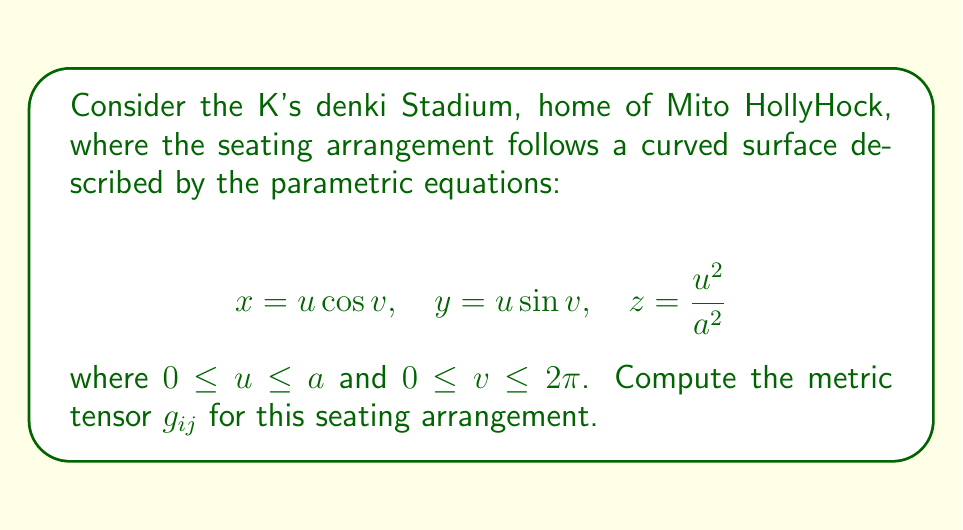Could you help me with this problem? Let's approach this step-by-step:

1) The metric tensor $g_{ij}$ is given by the dot product of the partial derivatives of the position vector with respect to the parameters:

   $$g_{ij} = \frac{\partial \mathbf{r}}{\partial x^i} \cdot \frac{\partial \mathbf{r}}{\partial x^j}$$

   where $\mathbf{r} = (x, y, z)$ and $(x^1, x^2) = (u, v)$.

2) Let's calculate the partial derivatives:

   $$\frac{\partial \mathbf{r}}{\partial u} = (\cos v, \sin v, \frac{2u}{a^2})$$
   $$\frac{\partial \mathbf{r}}{\partial v} = (-u\sin v, u\cos v, 0)$$

3) Now, let's compute each component of the metric tensor:

   $$g_{11} = \frac{\partial \mathbf{r}}{\partial u} \cdot \frac{\partial \mathbf{r}}{\partial u} = \cos^2 v + \sin^2 v + \frac{4u^2}{a^4} = 1 + \frac{4u^2}{a^4}$$

   $$g_{12} = g_{21} = \frac{\partial \mathbf{r}}{\partial u} \cdot \frac{\partial \mathbf{r}}{\partial v} = -u\sin v \cos v + u\sin v \cos v = 0$$

   $$g_{22} = \frac{\partial \mathbf{r}}{\partial v} \cdot \frac{\partial \mathbf{r}}{\partial v} = u^2\sin^2 v + u^2\cos^2 v = u^2$$

4) Therefore, the metric tensor is:

   $$g_{ij} = \begin{pmatrix} 
   1 + \frac{4u^2}{a^4} & 0 \\
   0 & u^2
   \end{pmatrix}$$

This metric tensor describes the geometry of the seating arrangement in K's denki Stadium, capturing the curvature and spacing of the seats.
Answer: $$g_{ij} = \begin{pmatrix} 
1 + \frac{4u^2}{a^4} & 0 \\
0 & u^2
\end{pmatrix}$$ 